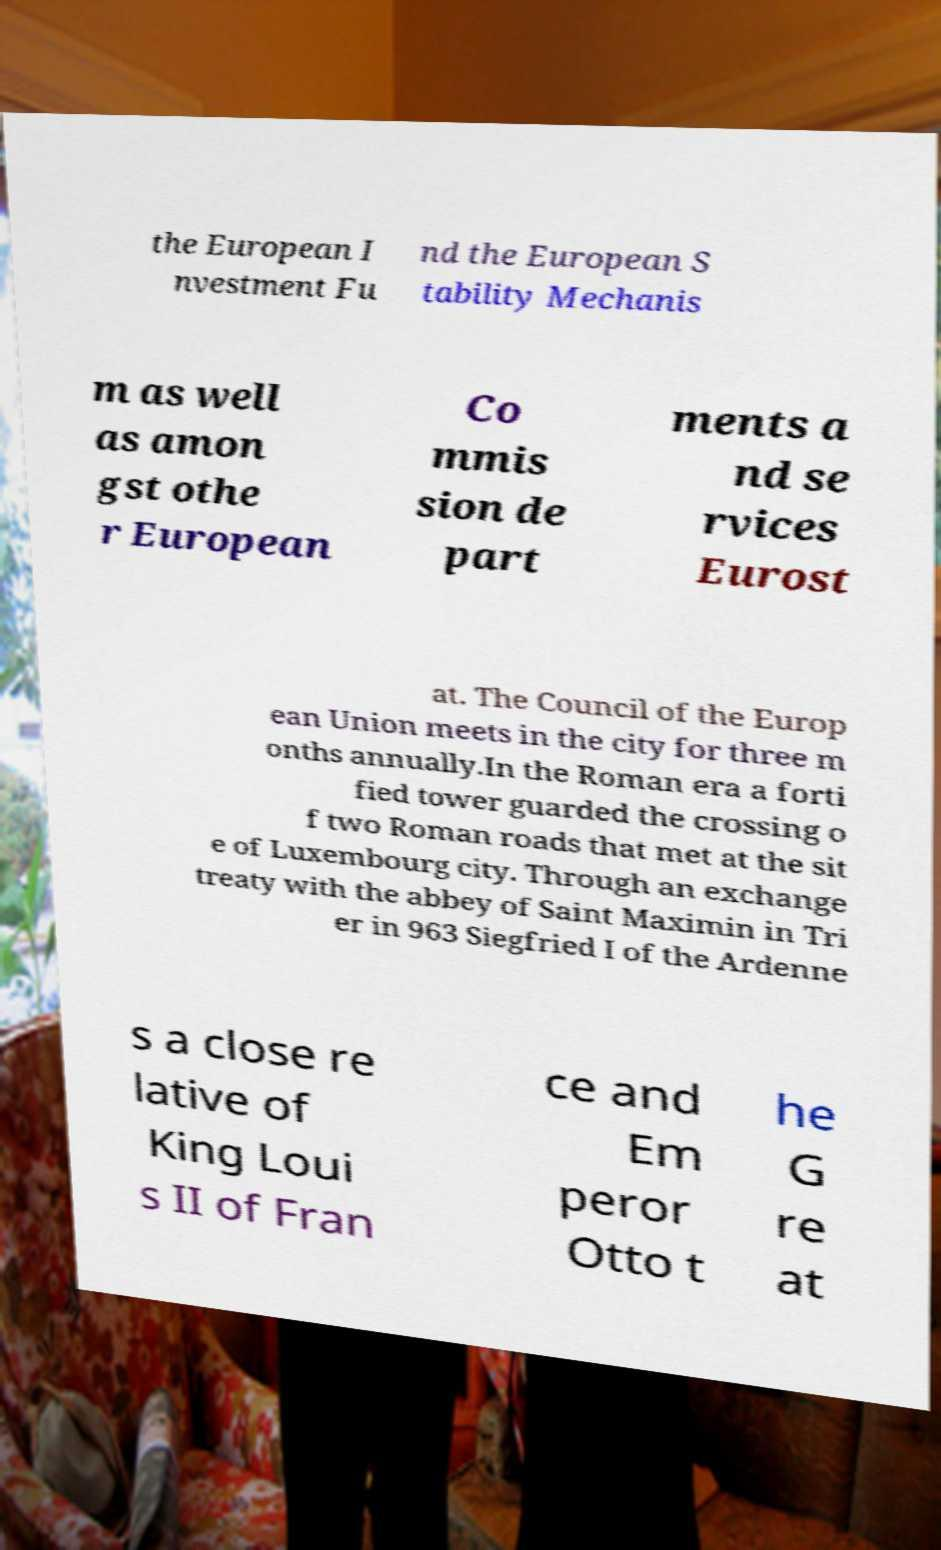Please identify and transcribe the text found in this image. the European I nvestment Fu nd the European S tability Mechanis m as well as amon gst othe r European Co mmis sion de part ments a nd se rvices Eurost at. The Council of the Europ ean Union meets in the city for three m onths annually.In the Roman era a forti fied tower guarded the crossing o f two Roman roads that met at the sit e of Luxembourg city. Through an exchange treaty with the abbey of Saint Maximin in Tri er in 963 Siegfried I of the Ardenne s a close re lative of King Loui s II of Fran ce and Em peror Otto t he G re at 